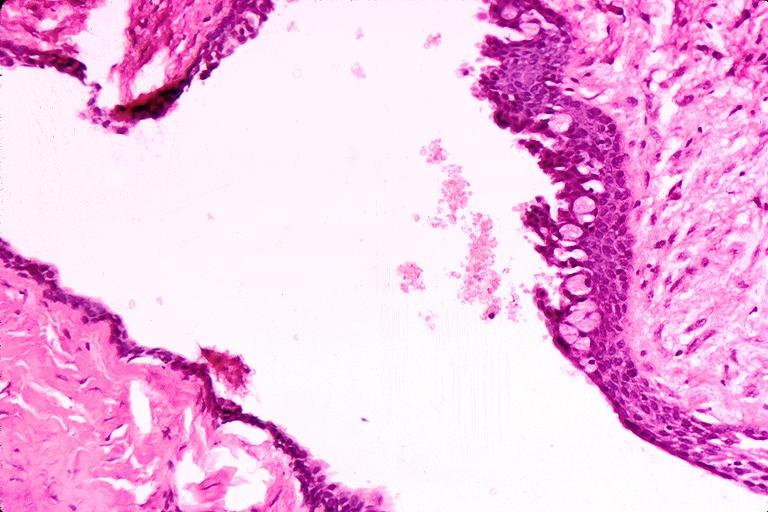s primary present?
Answer the question using a single word or phrase. No 